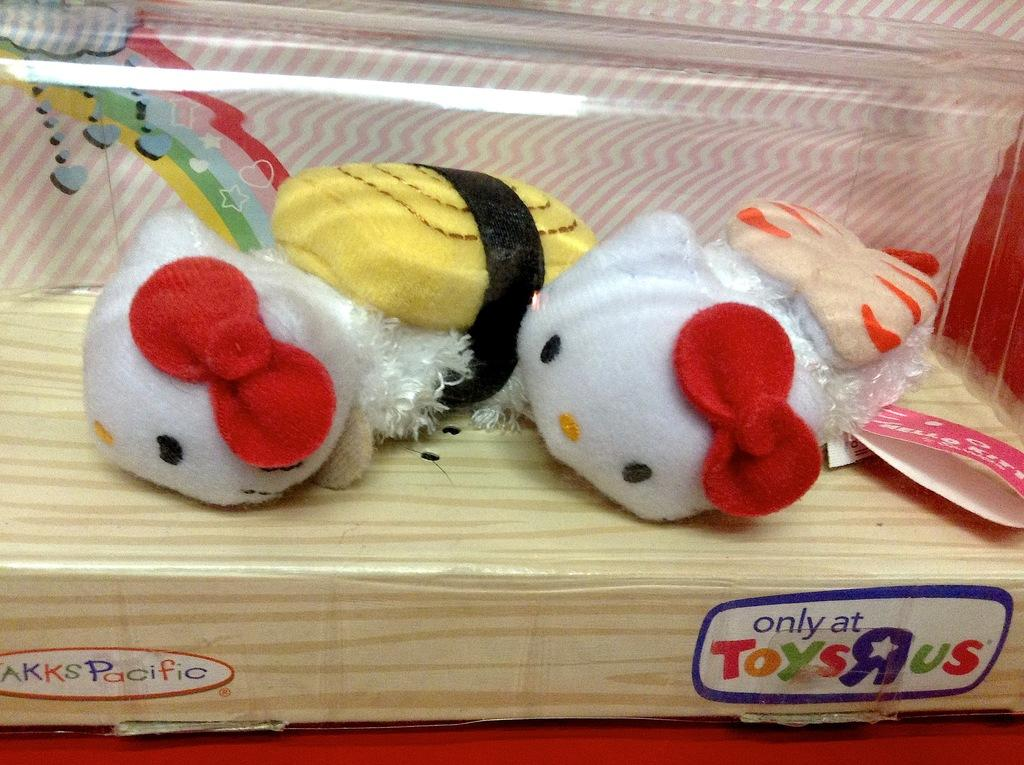What are the colors of the toys in the image? The toys in the image are white. What is the color of the box on which the toys are placed? The box is cream color. What is the color of the surface on which the box is placed? The surface is red color. How many family members can be seen in the image? There are no family members present in the image; it only features two white color toys on a cream color box placed on a red color surface. What type of polish is used on the toys in the image? There is no indication of any polish being used on the toys in the image; they are simply white color toys. 